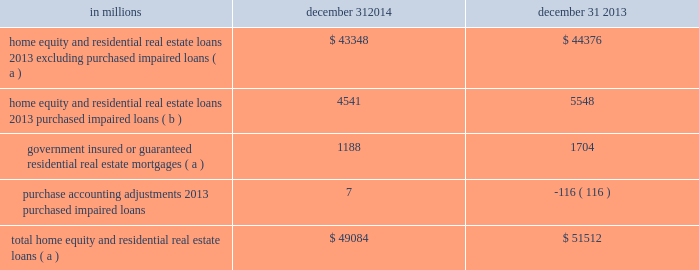Consumer lending asset classes home equity and residential real estate loan classes we use several credit quality indicators , including delinquency information , nonperforming loan information , updated credit scores , originated and updated ltv ratios , and geography , to monitor and manage credit risk within the home equity and residential real estate loan classes .
We evaluate mortgage loan performance by source originators and loan servicers .
A summary of asset quality indicators follows : delinquency/delinquency rates : we monitor trending of delinquency/delinquency rates for home equity and residential real estate loans .
See the asset quality section of this note 3 for additional information .
Nonperforming loans : we monitor trending of nonperforming loans for home equity and residential real estate loans .
See the asset quality section of this note 3 for additional information .
Credit scores : we use a national third-party provider to update fico credit scores for home equity loans and lines of credit and residential real estate loans at least quarterly .
The updated scores are incorporated into a series of credit management reports , which are utilized to monitor the risk in the loan classes .
Ltv ( inclusive of combined loan-to-value ( cltv ) for first and subordinate lien positions ) : at least annually , we update the property values of real estate collateral and calculate an updated ltv ratio .
For open-end credit lines secured by real estate in regions experiencing significant declines in property values , more frequent valuations may occur .
We examine ltv migration and stratify ltv into categories to monitor the risk in the loan classes .
Historically , we used , and we continue to use , a combination of original ltv and updated ltv for internal risk management and reporting purposes ( e.g. , line management , loss mitigation strategies ) .
In addition to the fact that estimated property values by their nature are estimates , given certain data limitations it is important to note that updated ltvs may be based upon management 2019s assumptions ( e.g. , if an updated ltv is not provided by the third-party service provider , home price index ( hpi ) changes will be incorporated in arriving at management 2019s estimate of updated ltv ) .
Geography : geographic concentrations are monitored to evaluate and manage exposures .
Loan purchase programs are sensitive to , and focused within , certain regions to manage geographic exposures and associated risks .
A combination of updated fico scores , originated and updated ltv ratios and geographic location assigned to home equity loans and lines of credit and residential real estate loans is used to monitor the risk in the loan classes .
Loans with higher fico scores and lower ltvs tend to have a lower level of risk .
Conversely , loans with lower fico scores , higher ltvs , and in certain geographic locations tend to have a higher level of risk .
Consumer purchased impaired loan class estimates of the expected cash flows primarily determine the valuation of consumer purchased impaired loans .
Consumer cash flow estimates are influenced by a number of credit related items , which include , but are not limited to : estimated real estate values , payment patterns , updated fico scores , the current economic environment , updated ltv ratios and the date of origination .
These key factors are monitored to help ensure that concentrations of risk are managed and cash flows are maximized .
See note 4 purchased loans for additional information .
Table 63 : home equity and residential real estate balances in millions december 31 december 31 .
( a ) represents recorded investment .
( b ) represents outstanding balance .
The pnc financial services group , inc .
2013 form 10-k 133 .
Were government insured or guaranteed residential real estate mortgages greater on 12/31/ 2014 than on12/31/ 2013? 
Computations: (1188 > 1704)
Answer: no. 